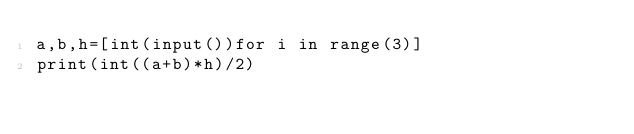<code> <loc_0><loc_0><loc_500><loc_500><_Python_>a,b,h=[int(input())for i in range(3)]
print(int((a+b)*h)/2)</code> 